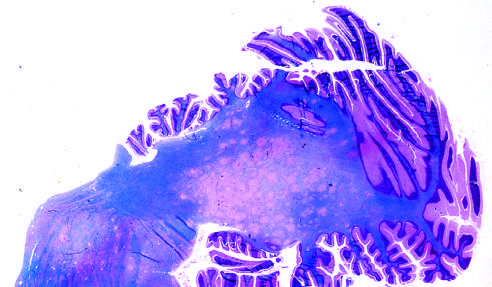s the section stained for myelin?
Answer the question using a single word or phrase. Yes 